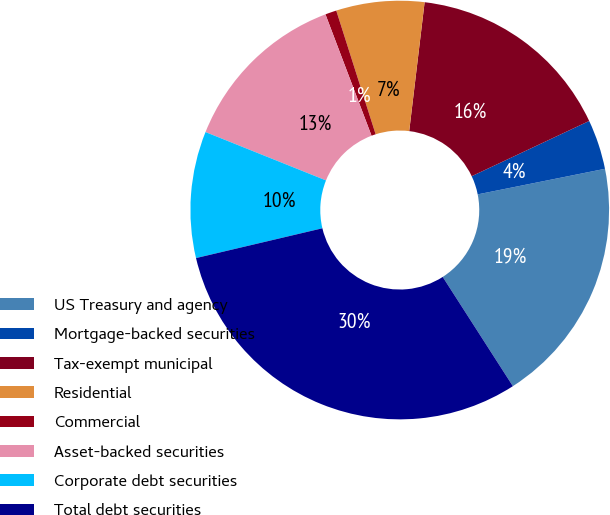<chart> <loc_0><loc_0><loc_500><loc_500><pie_chart><fcel>US Treasury and agency<fcel>Mortgage-backed securities<fcel>Tax-exempt municipal<fcel>Residential<fcel>Commercial<fcel>Asset-backed securities<fcel>Corporate debt securities<fcel>Total debt securities<nl><fcel>19.07%<fcel>3.84%<fcel>16.11%<fcel>6.8%<fcel>0.87%<fcel>13.15%<fcel>9.76%<fcel>30.4%<nl></chart> 